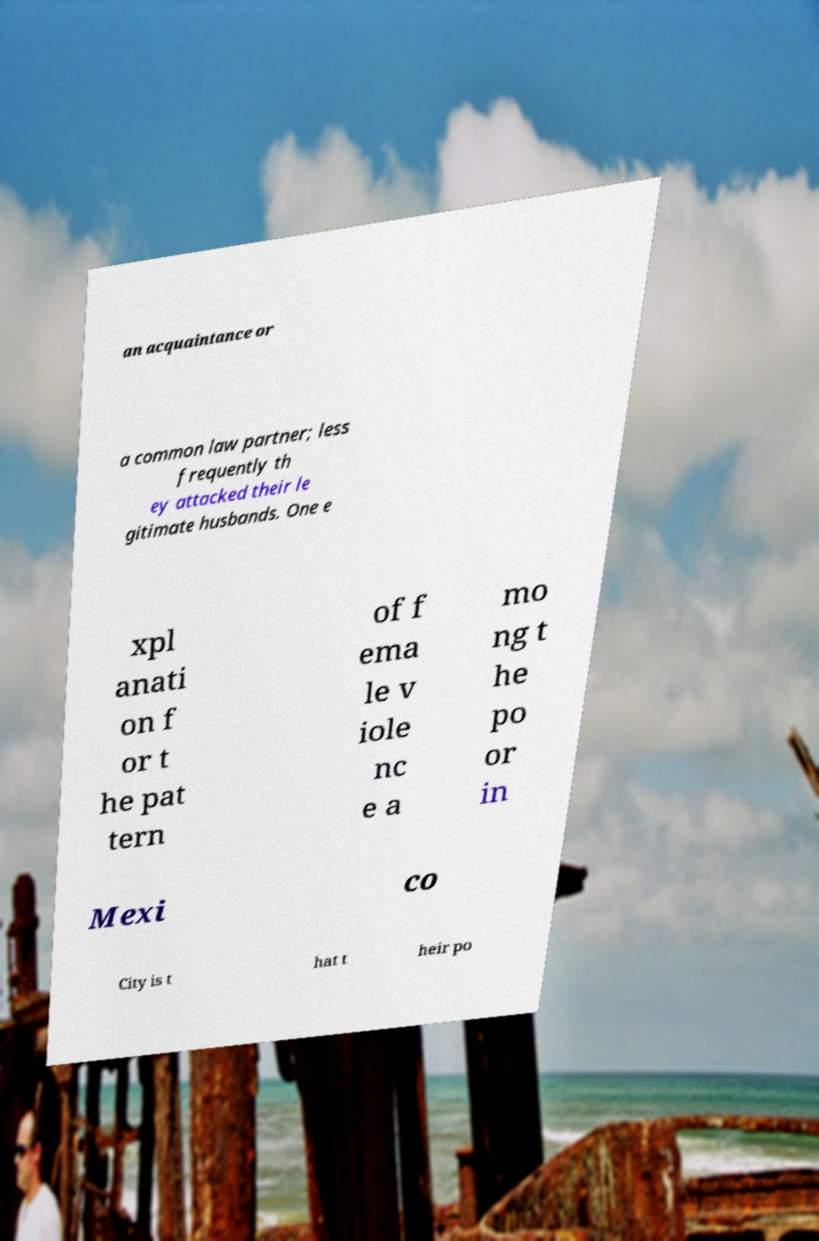Please identify and transcribe the text found in this image. an acquaintance or a common law partner; less frequently th ey attacked their le gitimate husbands. One e xpl anati on f or t he pat tern of f ema le v iole nc e a mo ng t he po or in Mexi co City is t hat t heir po 